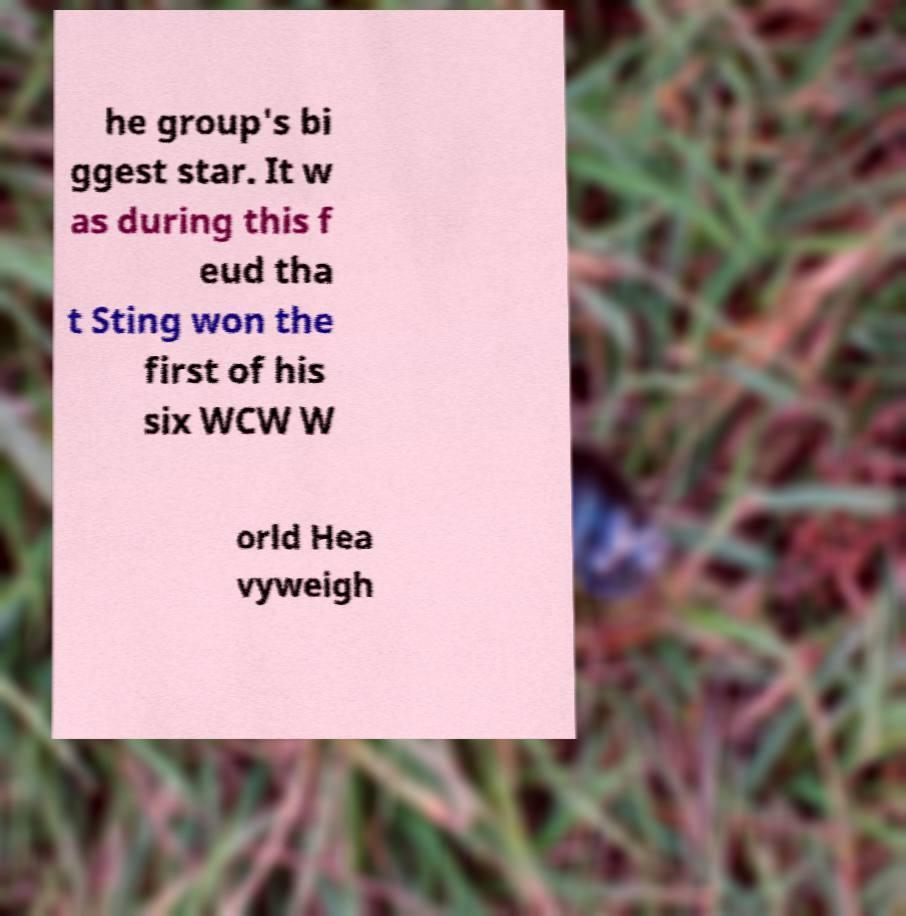Can you accurately transcribe the text from the provided image for me? he group's bi ggest star. It w as during this f eud tha t Sting won the first of his six WCW W orld Hea vyweigh 